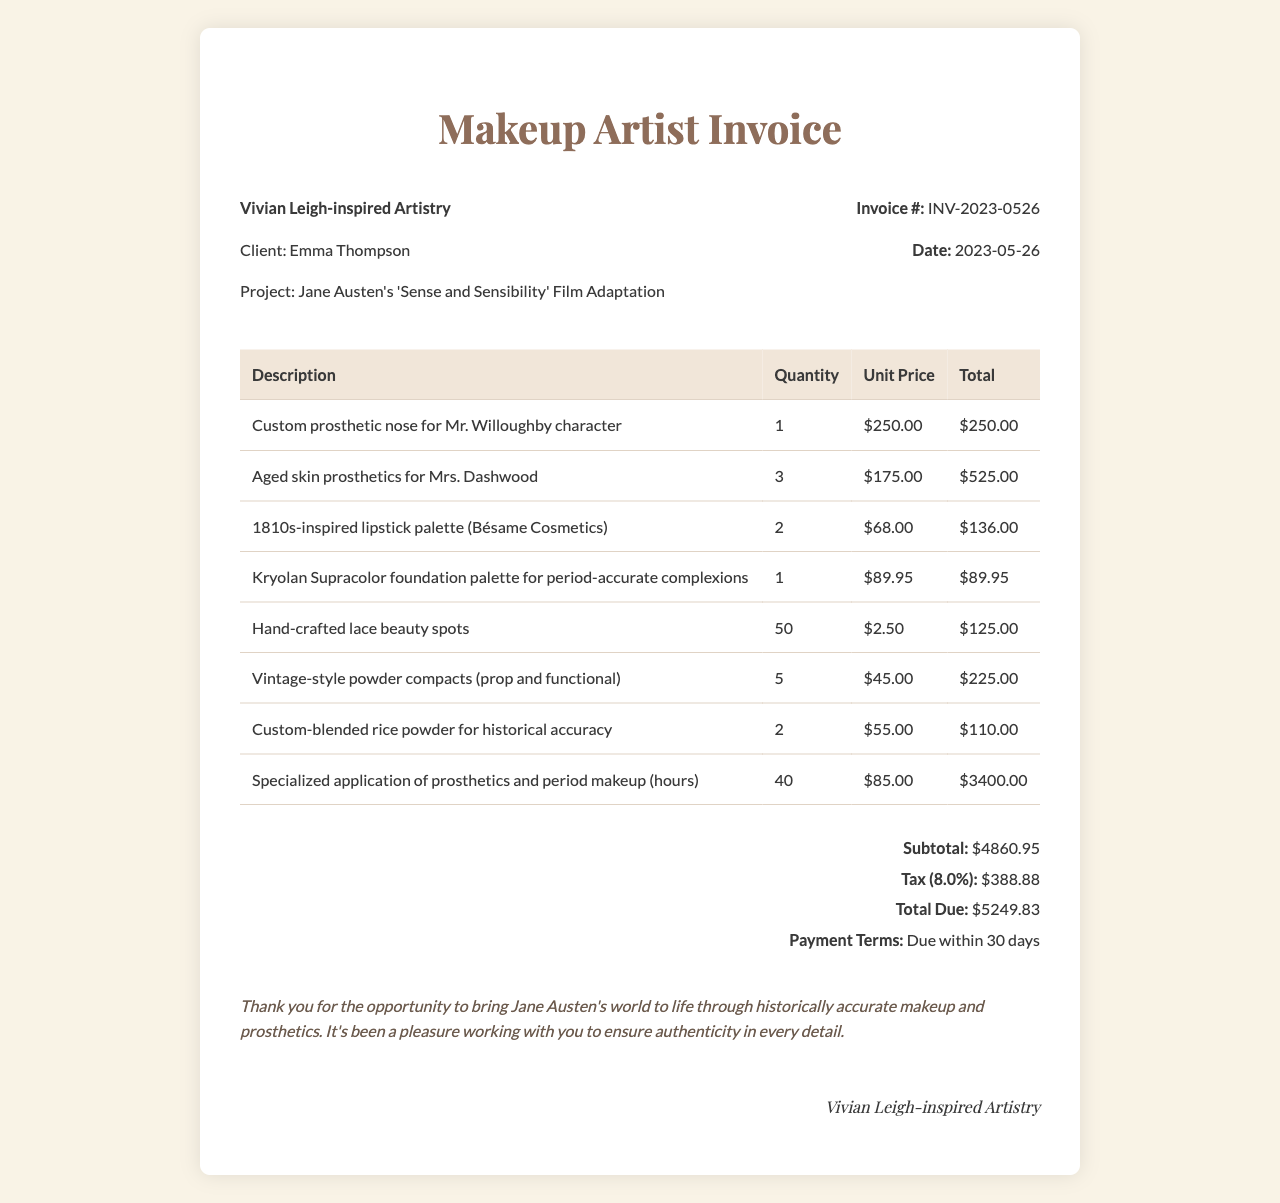What is the invoice number? The invoice number is a unique identifier for the transaction, which is listed in the document.
Answer: INV-2023-0526 Who is the client? The client is the individual or organization receiving the services, as mentioned in the invoice.
Answer: Emma Thompson What is the total due? The total due is the complete amount payable by the client at the end of the invoice.
Answer: $5249.83 How many custom prosthetic noses were created? The quantity of the custom prosthetic noses for the character mentioned in the invoice indicates how many were made.
Answer: 1 What is the tax amount? The tax amount is the calculated tax that needs to be added to the subtotal of the invoice.
Answer: $388.88 What was the project for this invoice? The project name indicates the title of the film or work that the makeup services pertained to.
Answer: Jane Austen's 'Sense and Sensibility' Film Adaptation What is the unit price of the aged skin prosthetics? The unit price is the cost assigned to each individual item of aged skin prosthetics listed.
Answer: $175.00 How many hours were billed for the specialized application of prosthetics and period makeup? This indicates the time spent applying the makeup and prosthetics as detailed in the invoice.
Answer: 40 What is the payment terms listed in the invoice? Payment terms outline when payment is expected from the client after receiving the invoice.
Answer: Due within 30 days 